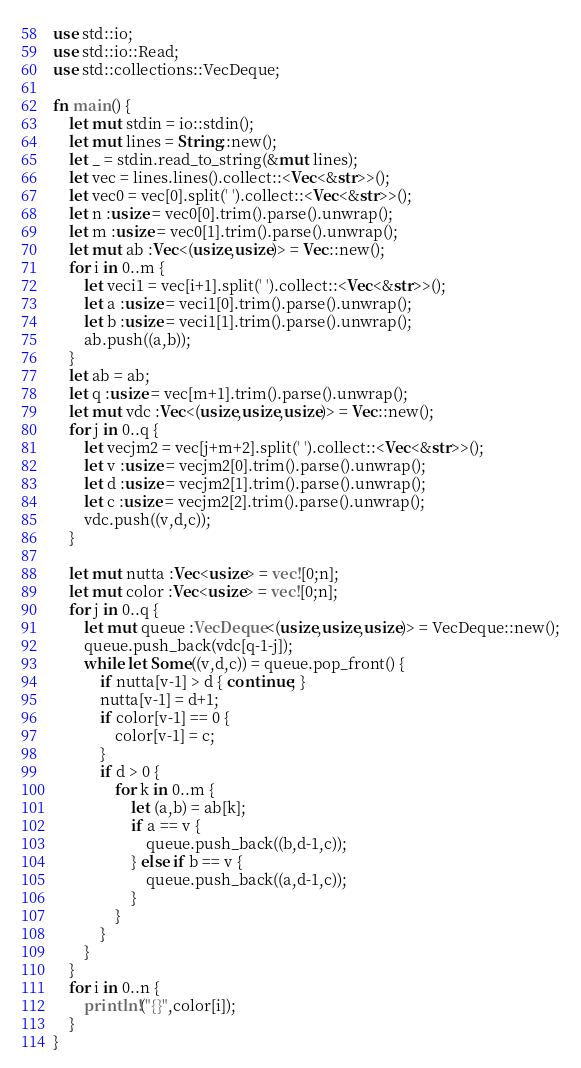<code> <loc_0><loc_0><loc_500><loc_500><_Rust_>use std::io;
use std::io::Read;
use std::collections::VecDeque;

fn main() {
    let mut stdin = io::stdin();
    let mut lines = String::new();
    let _ = stdin.read_to_string(&mut lines);
    let vec = lines.lines().collect::<Vec<&str>>();
    let vec0 = vec[0].split(' ').collect::<Vec<&str>>();
    let n :usize = vec0[0].trim().parse().unwrap();
    let m :usize = vec0[1].trim().parse().unwrap();
    let mut ab :Vec<(usize,usize)> = Vec::new();
    for i in 0..m {
        let veci1 = vec[i+1].split(' ').collect::<Vec<&str>>();
        let a :usize = veci1[0].trim().parse().unwrap();
        let b :usize = veci1[1].trim().parse().unwrap();
        ab.push((a,b));
    }
    let ab = ab;
    let q :usize = vec[m+1].trim().parse().unwrap();
    let mut vdc :Vec<(usize,usize,usize)> = Vec::new();
    for j in 0..q {
        let vecjm2 = vec[j+m+2].split(' ').collect::<Vec<&str>>();
        let v :usize = vecjm2[0].trim().parse().unwrap();
        let d :usize = vecjm2[1].trim().parse().unwrap();
        let c :usize = vecjm2[2].trim().parse().unwrap();
        vdc.push((v,d,c));
    }

    let mut nutta :Vec<usize> = vec![0;n];
    let mut color :Vec<usize> = vec![0;n];
    for j in 0..q {
        let mut queue :VecDeque<(usize,usize,usize)> = VecDeque::new();
        queue.push_back(vdc[q-1-j]);
        while let Some((v,d,c)) = queue.pop_front() {
            if nutta[v-1] > d { continue; }
            nutta[v-1] = d+1;
            if color[v-1] == 0 {
                color[v-1] = c;
            }
            if d > 0 {
                for k in 0..m {
                    let (a,b) = ab[k];
                    if a == v {
                        queue.push_back((b,d-1,c));
                    } else if b == v {
                        queue.push_back((a,d-1,c));
                    }
                }
            }
        }
    }
    for i in 0..n {
        println!("{}",color[i]);
    }
}
</code> 